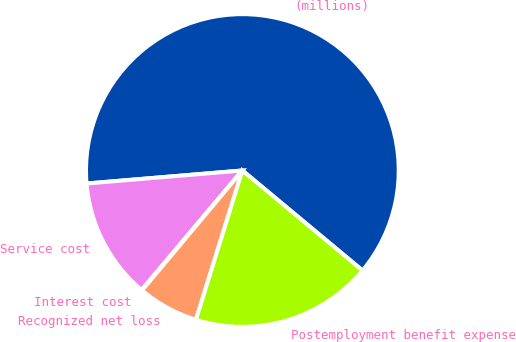Convert chart. <chart><loc_0><loc_0><loc_500><loc_500><pie_chart><fcel>(millions)<fcel>Service cost<fcel>Interest cost<fcel>Recognized net loss<fcel>Postemployment benefit expense<nl><fcel>62.37%<fcel>12.52%<fcel>0.06%<fcel>6.29%<fcel>18.75%<nl></chart> 